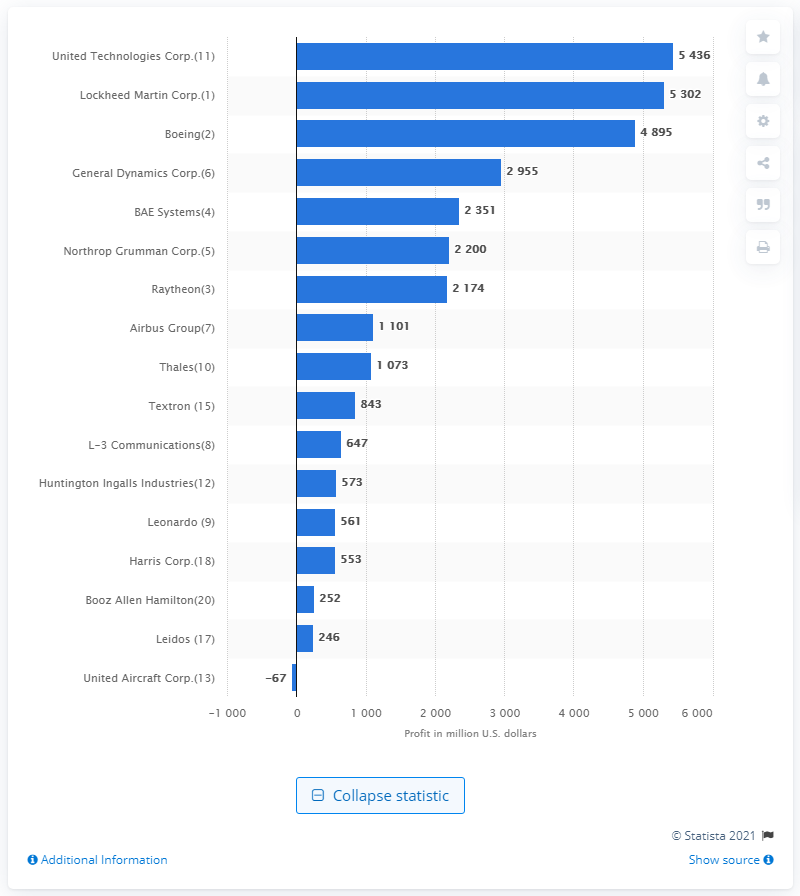Specify some key components in this picture. United Technologies reported a profit of $54,360 in 2016. 